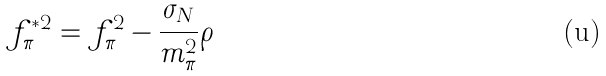Convert formula to latex. <formula><loc_0><loc_0><loc_500><loc_500>f _ { \pi } ^ { * 2 } = f _ { \pi } ^ { 2 } - \frac { \sigma _ { N } } { m _ { \pi } ^ { 2 } } \rho</formula> 